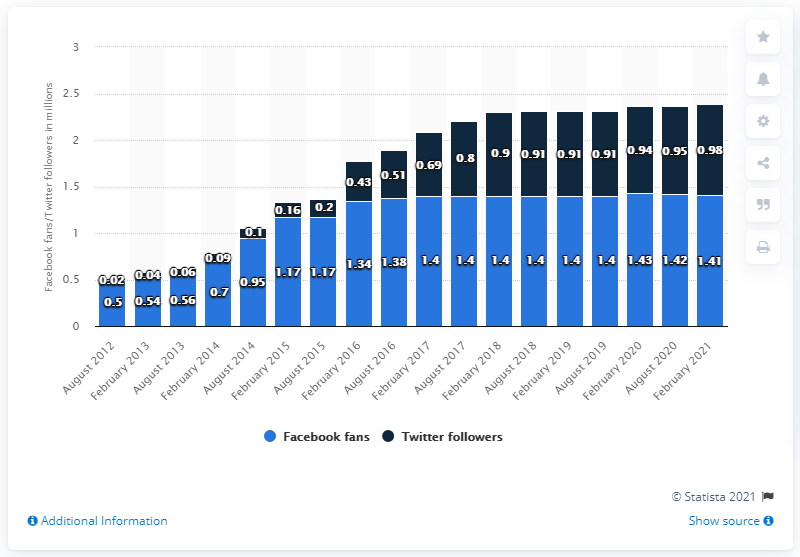Indicate a few pertinent items in this graphic. As of February 2021, the Arizona Cardinals football team had 1.41 million Facebook followers. 